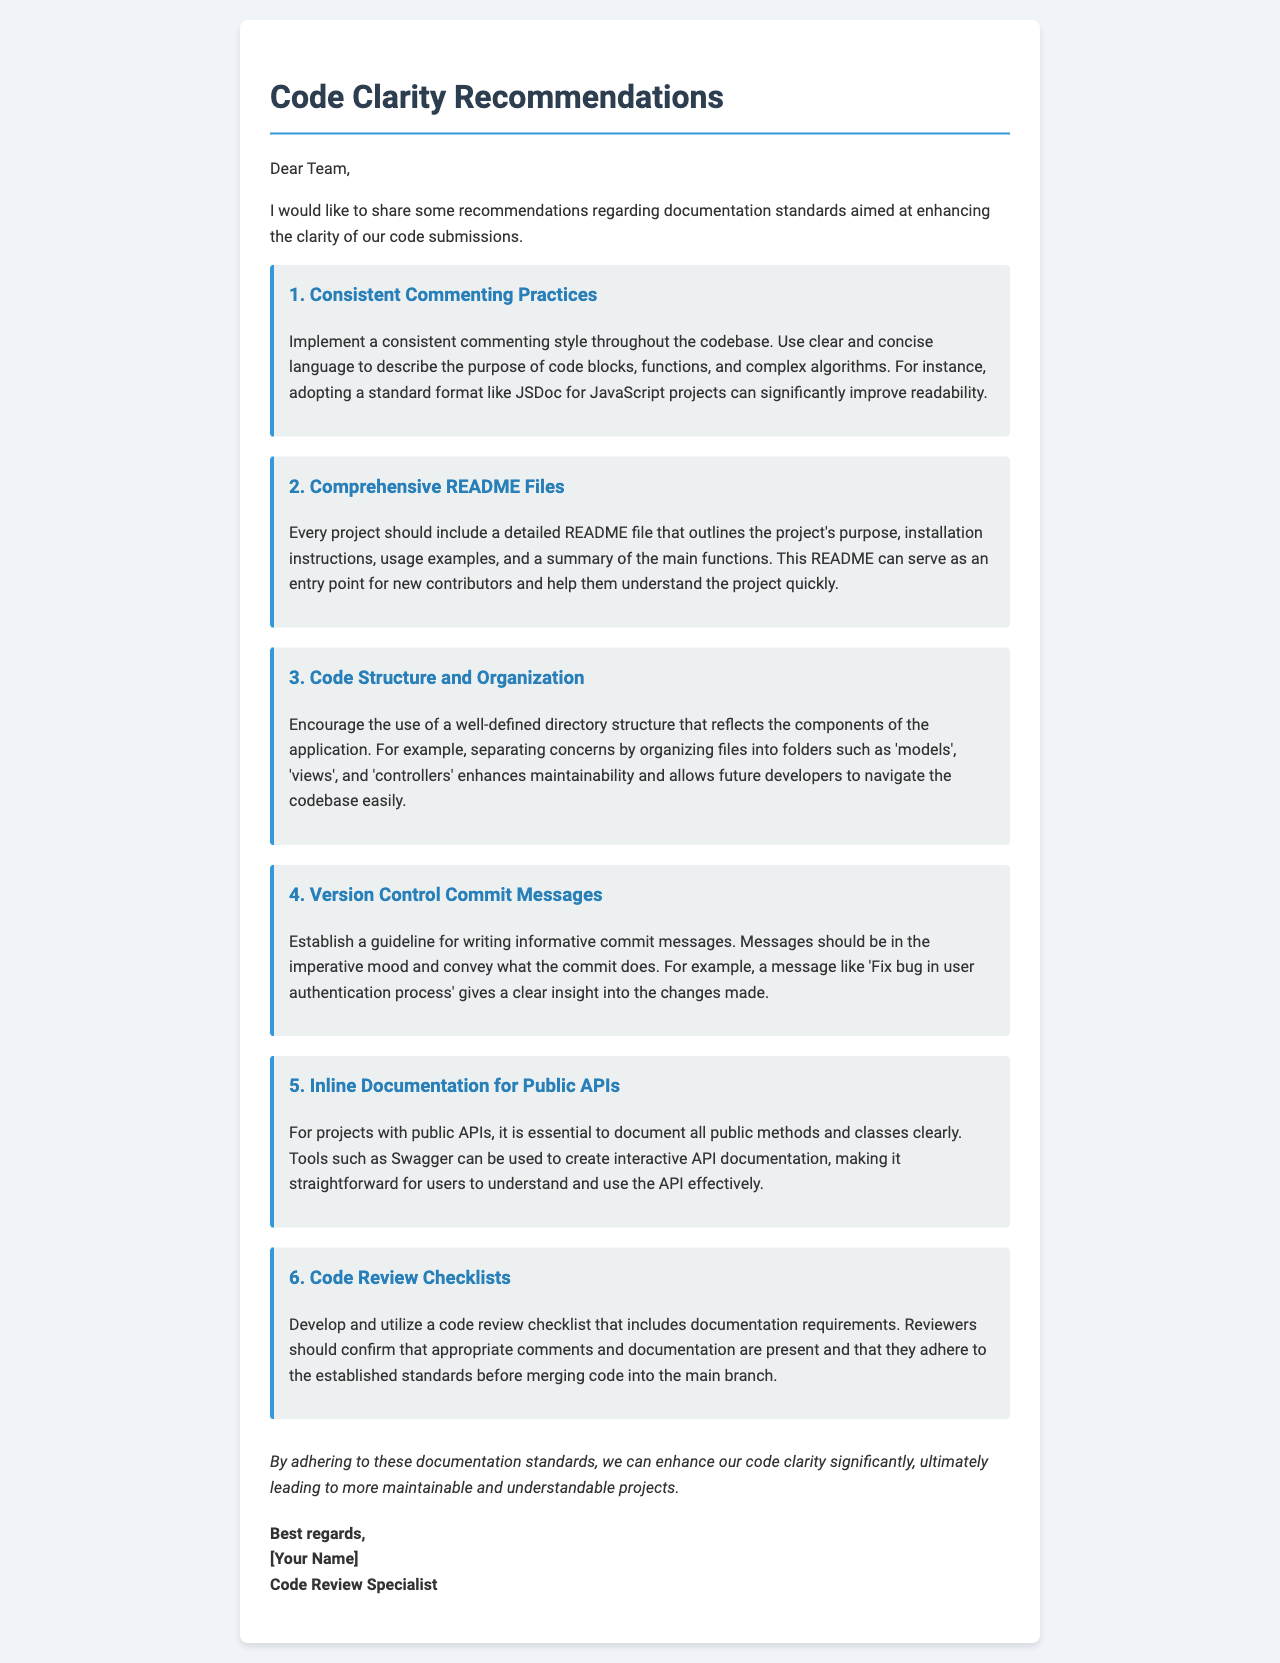What is the title of the document? The title is presented in the document as the main header, located at the top.
Answer: Code Clarity Recommendations How many recommendations are listed in the document? The document outlines six specific recommendations to improve code clarity.
Answer: 6 What is the first recommendation? The first recommendation is explicitly stated in the document as the initial suggestion for improving clarity.
Answer: Consistent Commenting Practices What should every project include according to the recommendations? The document specifies an important inclusion for every project, clearly stated in the relevant section.
Answer: Comprehensive README Files What is suggested for version control commit messages? The document provides specific instructions regarding the style and content of commit messages.
Answer: Informative commit messages What is the purpose of the code review checklist mentioned? The document indicates that the checklist serves a specific purpose in the review process.
Answer: Documentation requirements 